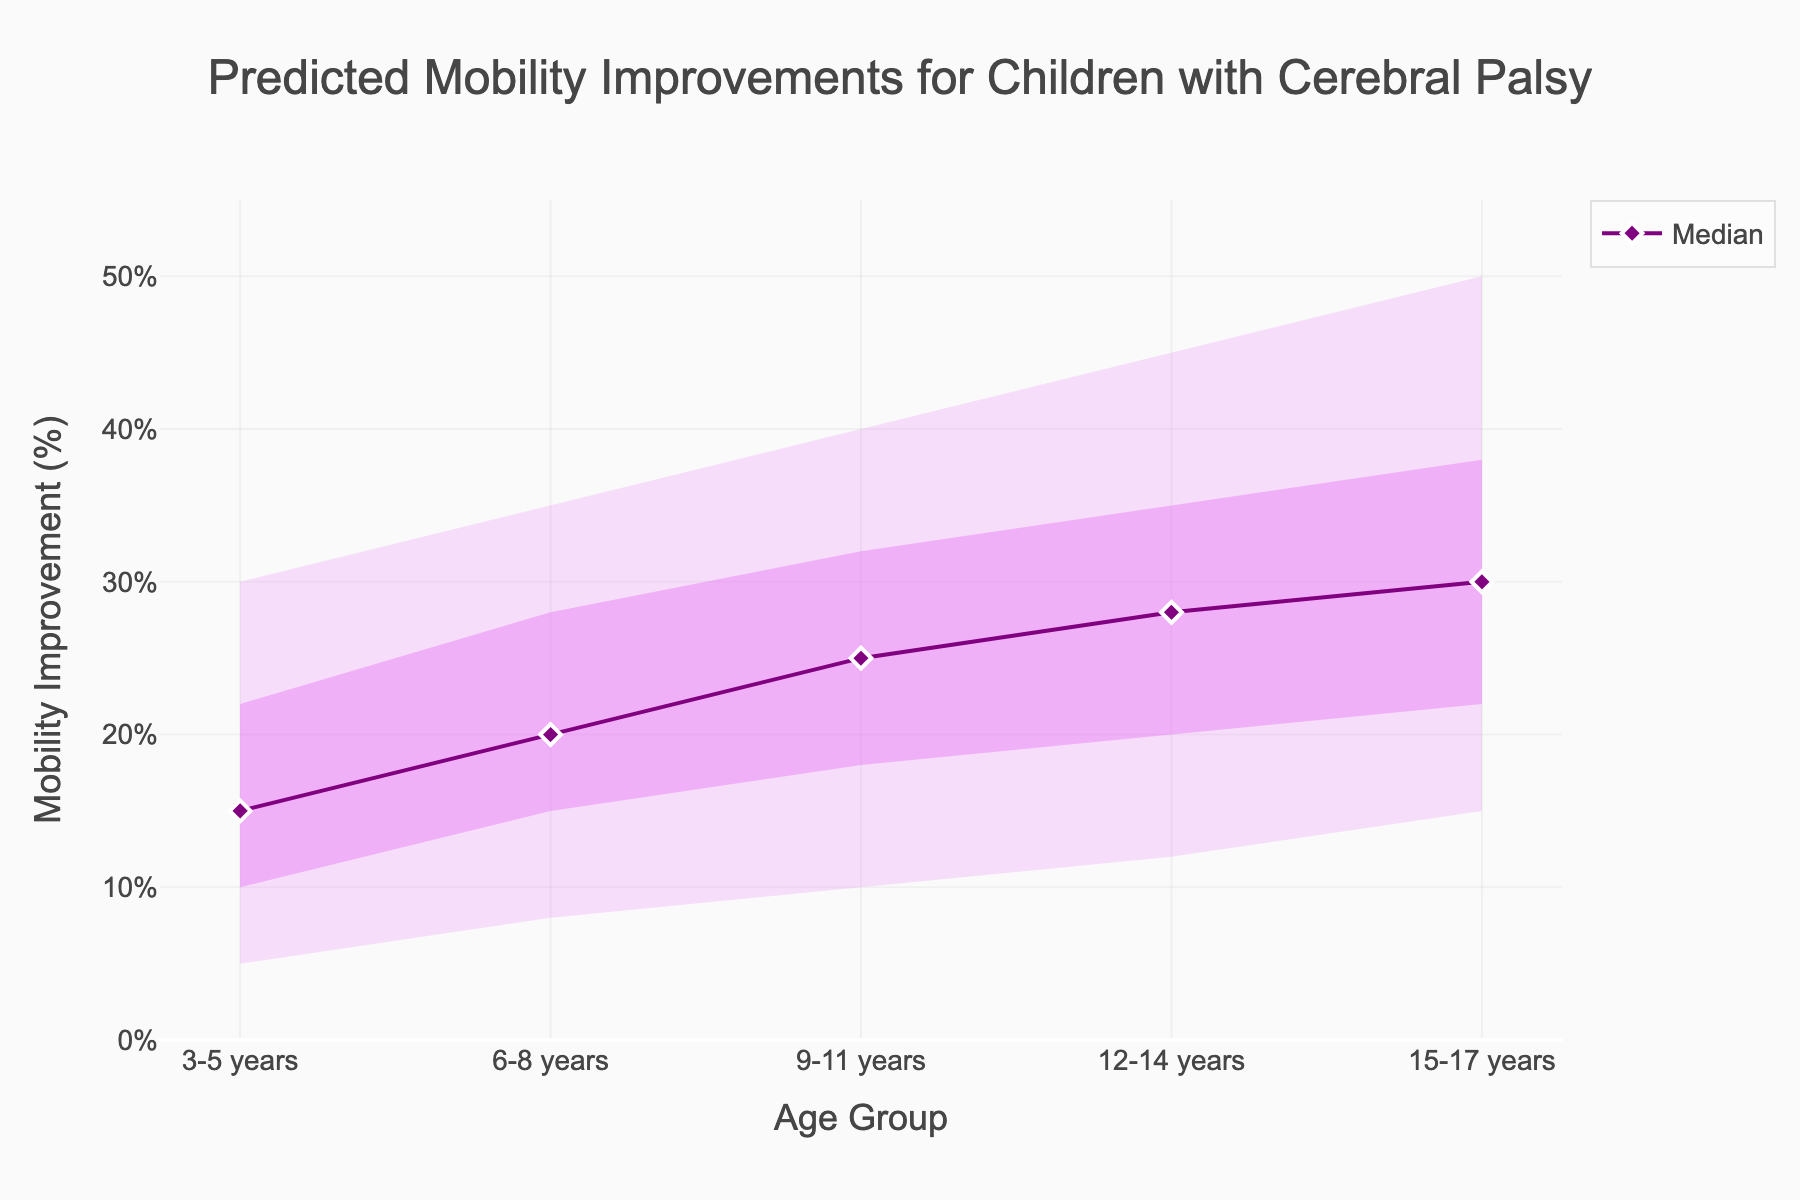what is the title of the chart? Look at the very top of the chart where the title is typically located and read it.
Answer: Predicted Mobility Improvements for Children with Cerebral Palsy Which age group has the highest median mobility improvement? Find the median values for each age group in the chart and identify the highest one.
Answer: 15-17 years What is the range of predicted mobility improvements for the 6-8 years age group? Look at the lower bound and the upper bound of the 6-8 years age group on the chart.
Answer: 8% to 35% How much higher is the upper bound for the 15-17 years age group compared to the 3-5 years age group? Find the upper bound values for both age groups and subtract the upper bound for 3-5 years from the upper bound for 15-17 years.
Answer: 20% Which age group has the lowest 10th percentile mobility improvement, and what is the value? Find the 10th percentile values for each age group and identify the lowest one.
Answer: 3-5 years, 10% Compare the median mobility improvement between the 9-11 years and 12-14 years age groups. Find the median values for both age groups and compare them.
Answer: 25% and 28% How much does the median mobility improvement increase from the 3-5 years age group to the 12-14 years age group? Find the median values for both age groups and subtract the median for 3-5 years from the median for 12-14 years.
Answer: 13% What is the full range of predicted mobility improvements for all age groups? Find the minimum lower bound and the maximum upper bound across all age groups.
Answer: 5% to 50% Which age group shows the narrowest 80% range of mobility improvement (from 10th to 90th percentile)? Calculate the range by subtracting the 10th percentile from the 90th percentile for all age groups, and identify the smallest difference.
Answer: 3-5 years What is the increase in the lower bound of mobility improvement from the 3-5 years age group to the 15-17 years age group? Find the lower bound values for both age groups and subtract the lower bound for 3-5 years from the lower bound for 15-17 years.
Answer: 10% 